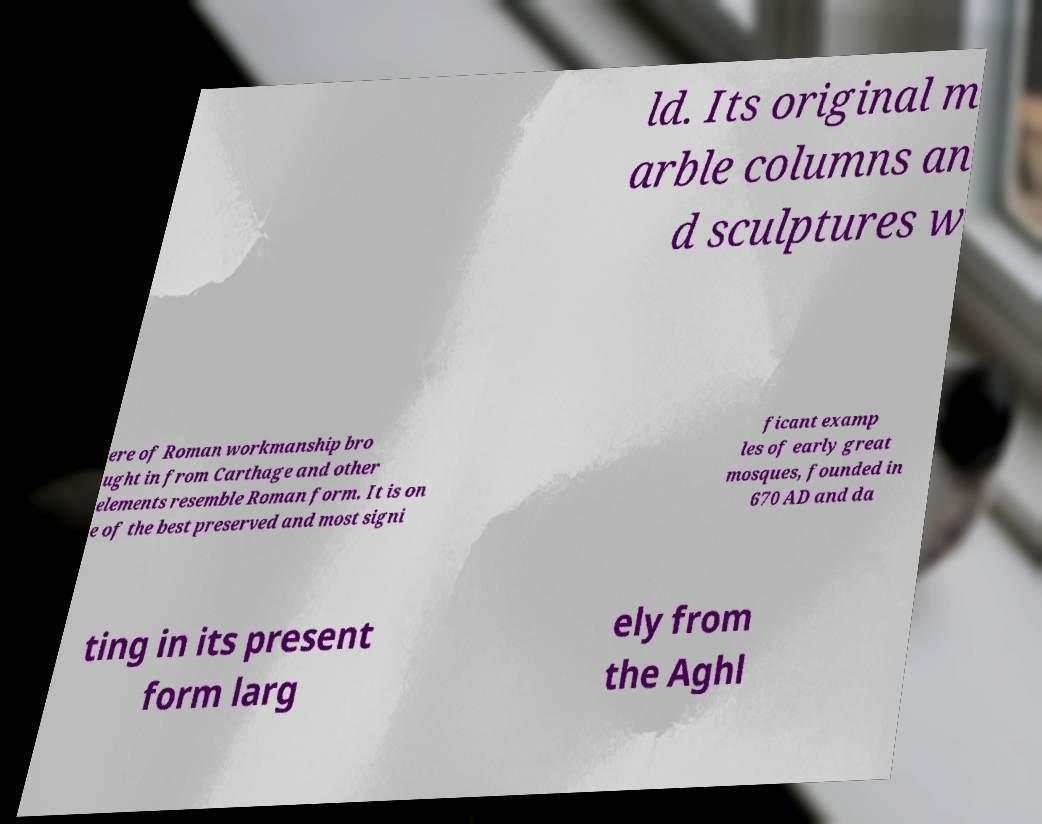Could you extract and type out the text from this image? ld. Its original m arble columns an d sculptures w ere of Roman workmanship bro ught in from Carthage and other elements resemble Roman form. It is on e of the best preserved and most signi ficant examp les of early great mosques, founded in 670 AD and da ting in its present form larg ely from the Aghl 